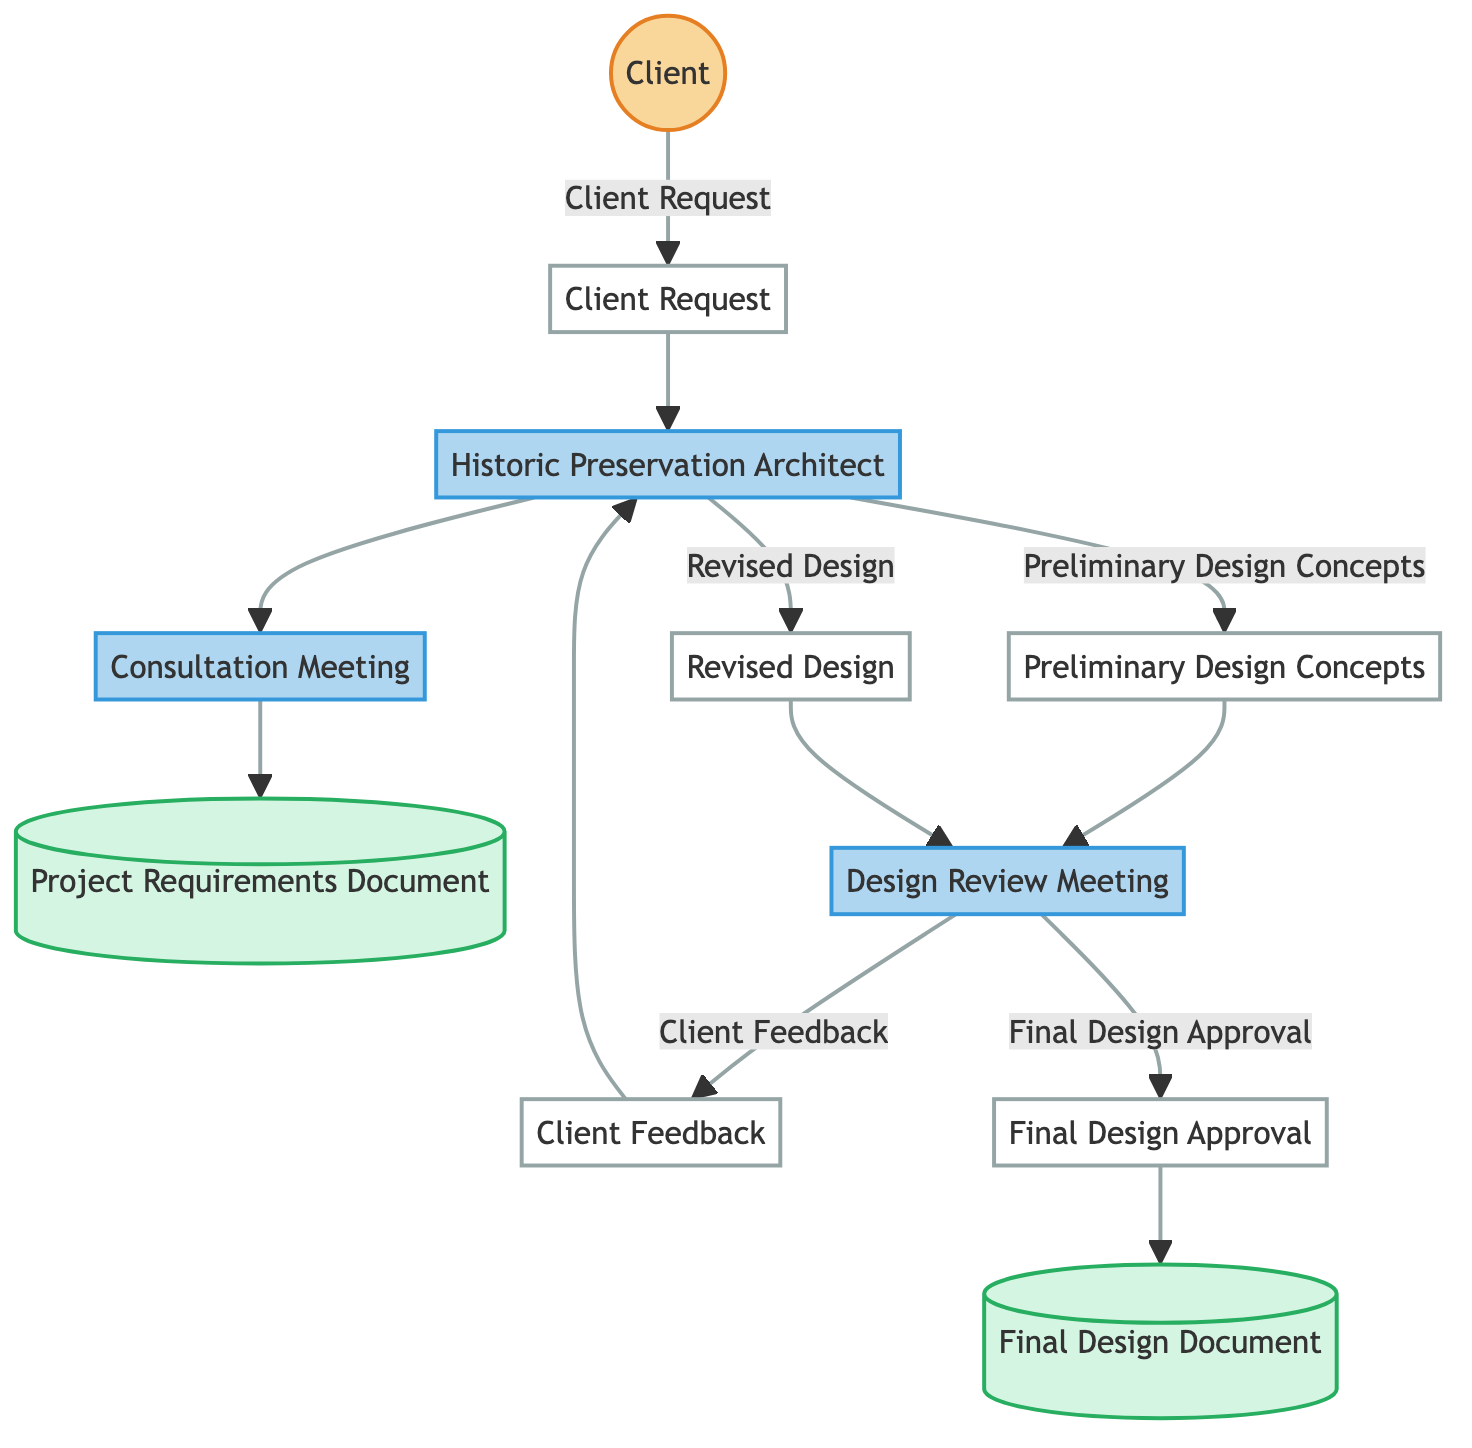What is the first step in the process? The first step in the process is the "Client Request," which is the initial input from the client regarding their project.
Answer: Client Request How many processes are in the diagram? There are four processes in the diagram, which are the "Historic Preservation Architect," "Consultation Meeting," "Design Review Meeting," and "Final Design Approval."
Answer: Four What does the "Historic Preservation Architect" receive after the "Client Request"? The "Historic Preservation Architect" receives the "Client Request" after the initial submission from the client, which defines the project requirements.
Answer: Client Request Which document outlines detailed requirements and expectations for the project? The document that outlines the detailed requirements and expectations for the project is the "Project Requirements Document."
Answer: Project Requirements Document What happens after the "Client Feedback" is received? After the "Client Feedback" is received, the "Historic Preservation Architect" uses this feedback to create a "Revised Design."
Answer: Revised Design What type of node is the "Client"? The "Client" is categorized as an "external_entity," indicating that it is an outside party involved in the project.
Answer: external_entity Which process leads to the client's final approval? The process that leads to the client's final approval is the "Design Review Meeting," where the architect presents the design for approval.
Answer: Design Review Meeting How many data stores are included in the diagram? There are two data stores included in the diagram, which are the "Project Requirements Document" and the "Final Design Document."
Answer: Two What is created as input to the "Design Review Meeting"? The input to the "Design Review Meeting" is the "Preliminary Design Concepts," which are initial design ideas developed by the architect.
Answer: Preliminary Design Concepts 